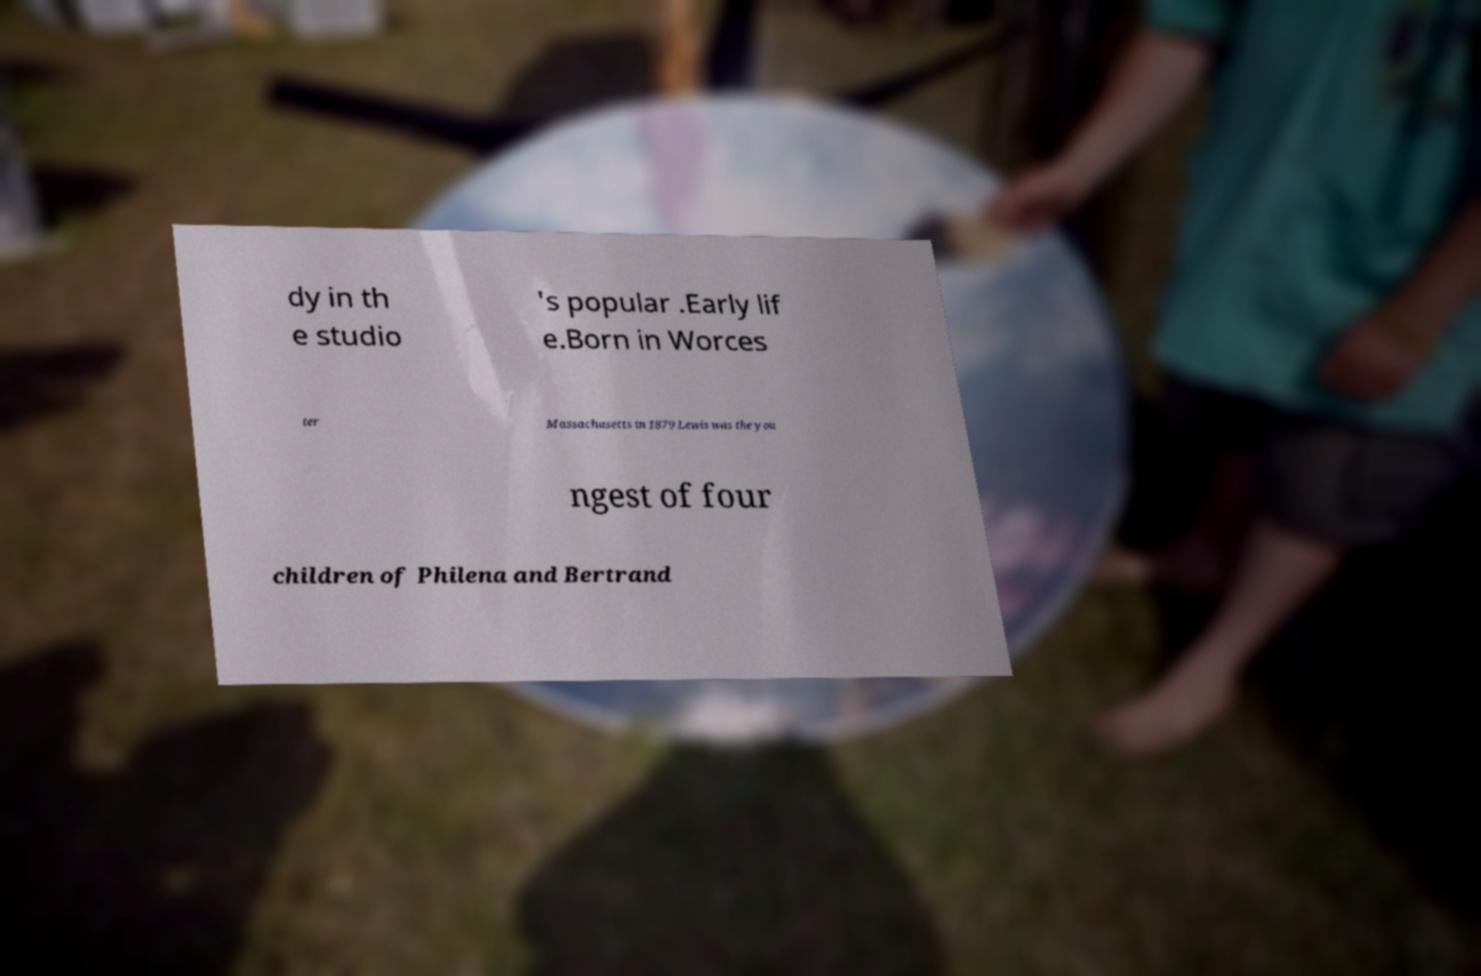There's text embedded in this image that I need extracted. Can you transcribe it verbatim? dy in th e studio 's popular .Early lif e.Born in Worces ter Massachusetts in 1879 Lewis was the you ngest of four children of Philena and Bertrand 